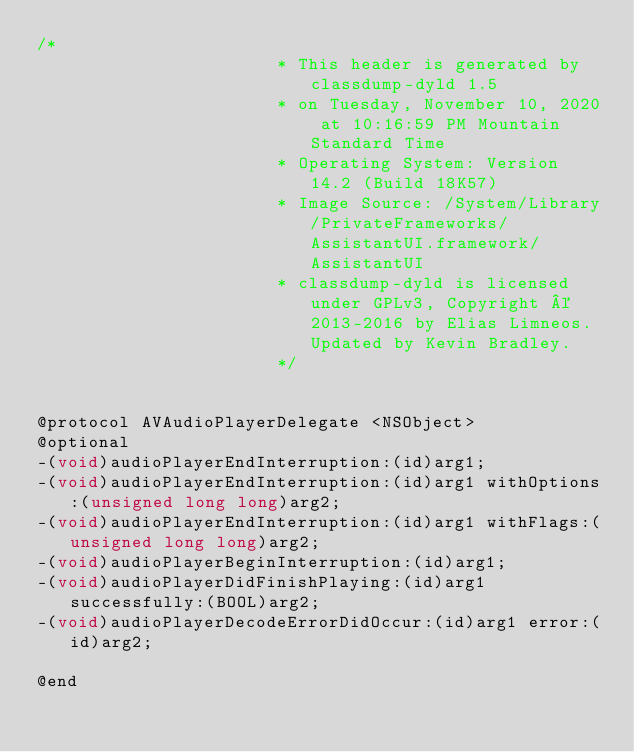<code> <loc_0><loc_0><loc_500><loc_500><_C_>/*
                       * This header is generated by classdump-dyld 1.5
                       * on Tuesday, November 10, 2020 at 10:16:59 PM Mountain Standard Time
                       * Operating System: Version 14.2 (Build 18K57)
                       * Image Source: /System/Library/PrivateFrameworks/AssistantUI.framework/AssistantUI
                       * classdump-dyld is licensed under GPLv3, Copyright © 2013-2016 by Elias Limneos. Updated by Kevin Bradley.
                       */


@protocol AVAudioPlayerDelegate <NSObject>
@optional
-(void)audioPlayerEndInterruption:(id)arg1;
-(void)audioPlayerEndInterruption:(id)arg1 withOptions:(unsigned long long)arg2;
-(void)audioPlayerEndInterruption:(id)arg1 withFlags:(unsigned long long)arg2;
-(void)audioPlayerBeginInterruption:(id)arg1;
-(void)audioPlayerDidFinishPlaying:(id)arg1 successfully:(BOOL)arg2;
-(void)audioPlayerDecodeErrorDidOccur:(id)arg1 error:(id)arg2;

@end

</code> 